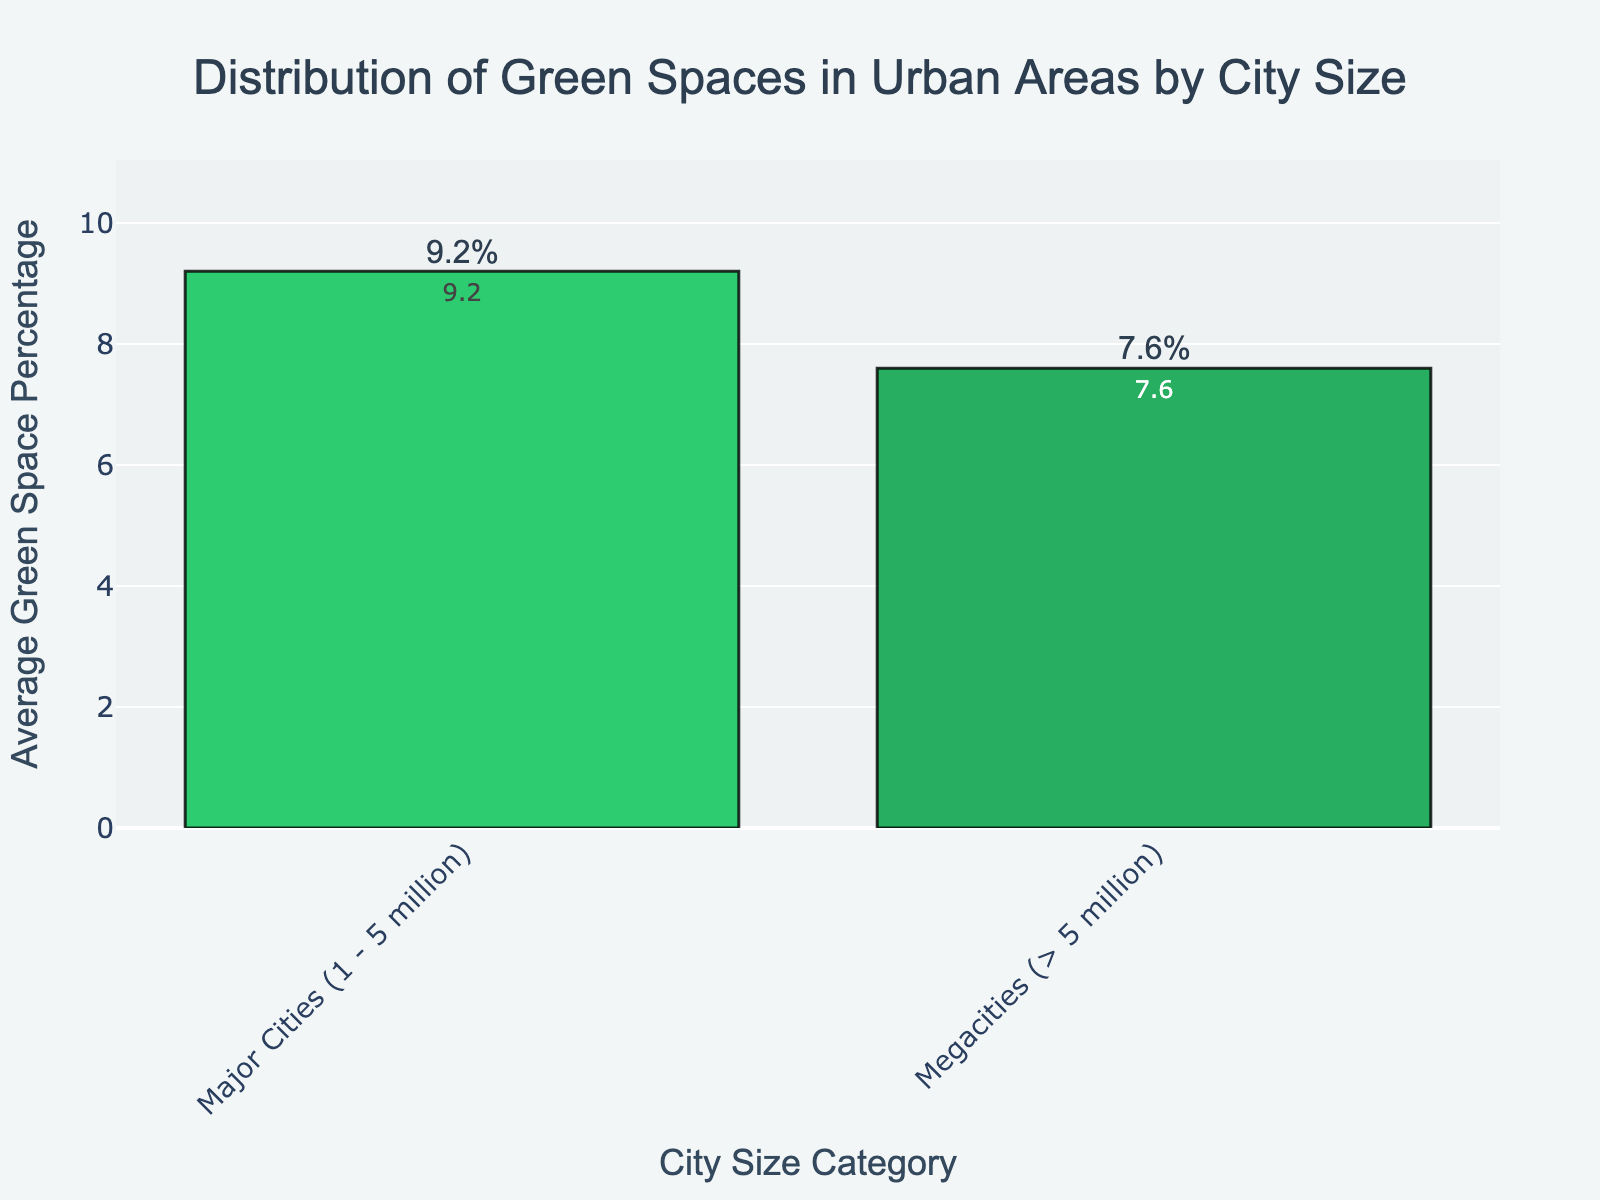Which city size category has the higher average green space percentage? By visually comparing the bars representing different city sizes, we can see that the bar for "Major Cities (1 - 5 million)" is taller than the bar for "Megacities (> 5 million)," indicating a higher average green space percentage.
Answer: Major Cities (1 - 5 million) How much more average green space percentage do Major Cities (1 - 5 million) have compared to Megacities (> 5 million)? To find the difference in average green space percentage between the two categories, we subtract the percentage for Megacities from the percentage for Major Cities: 9.2% - 7.6% = 1.6%.
Answer: 1.6% What is the combined average green space percentage of both city size categories? By adding the average green space percentages of both categories, we get: 9.2% + 7.6% = 16.8%.
Answer: 16.8% Between Major Cities (1 - 5 million) and Megacities (> 5 million), which category’s green space percentage is closer to 10%? By comparing the percentages to 10%, we find: The difference for Major Cities is 10% - 9.2% = 0.8%, and for Megacities, it is 10% - 7.6% = 2.4%. Since 0.8% is smaller than 2.4%, Major Cities are closer to 10%.
Answer: Major Cities (1 - 5 million) What percentage of the total average green space distribution is represented by Major Cities (1 - 5 million)? To calculate the percentage represented by Major Cities, divide their average green space percentage by the combined total percentage and multiply by 100: (9.2 / 16.8) * 100 ≈ 54.76%.
Answer: ≈ 54.76% Is the difference between the highest and lowest average green space percentage greater than 1.5%? To check if the difference is greater than 1.5%, calculate the difference: 9.2% - 7.6% = 1.6%. Since 1.6% > 1.5%, the difference is indeed greater than 1.5%.
Answer: Yes If another city size category with an average green space percentage of 8.0% was added, would this new category have an average green space percentage higher or lower than the total average of the original two categories? First, find the average of the original two categories: (9.2% + 7.6%) / 2 = 8.4%. Since 8.0% is lower than 8.4%, the new category would have a lower average green space percentage than the total average of the original categories.
Answer: Lower 